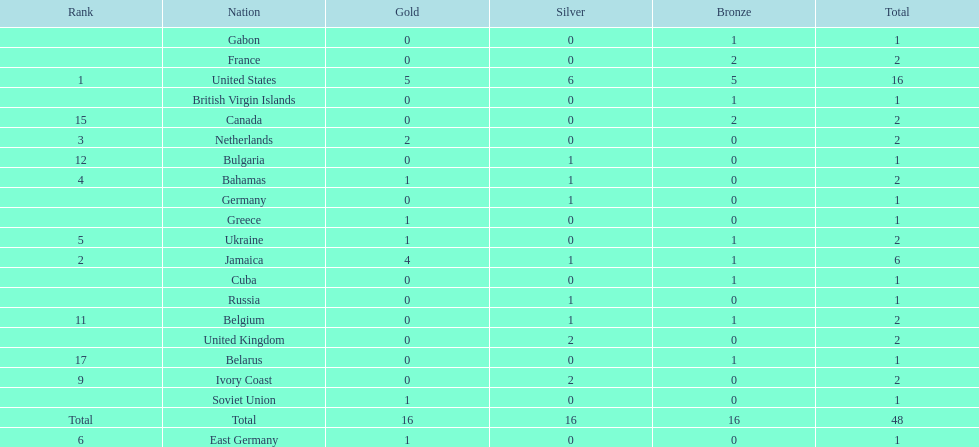What is the average number of gold medals won by the top 5 nations? 2.6. 